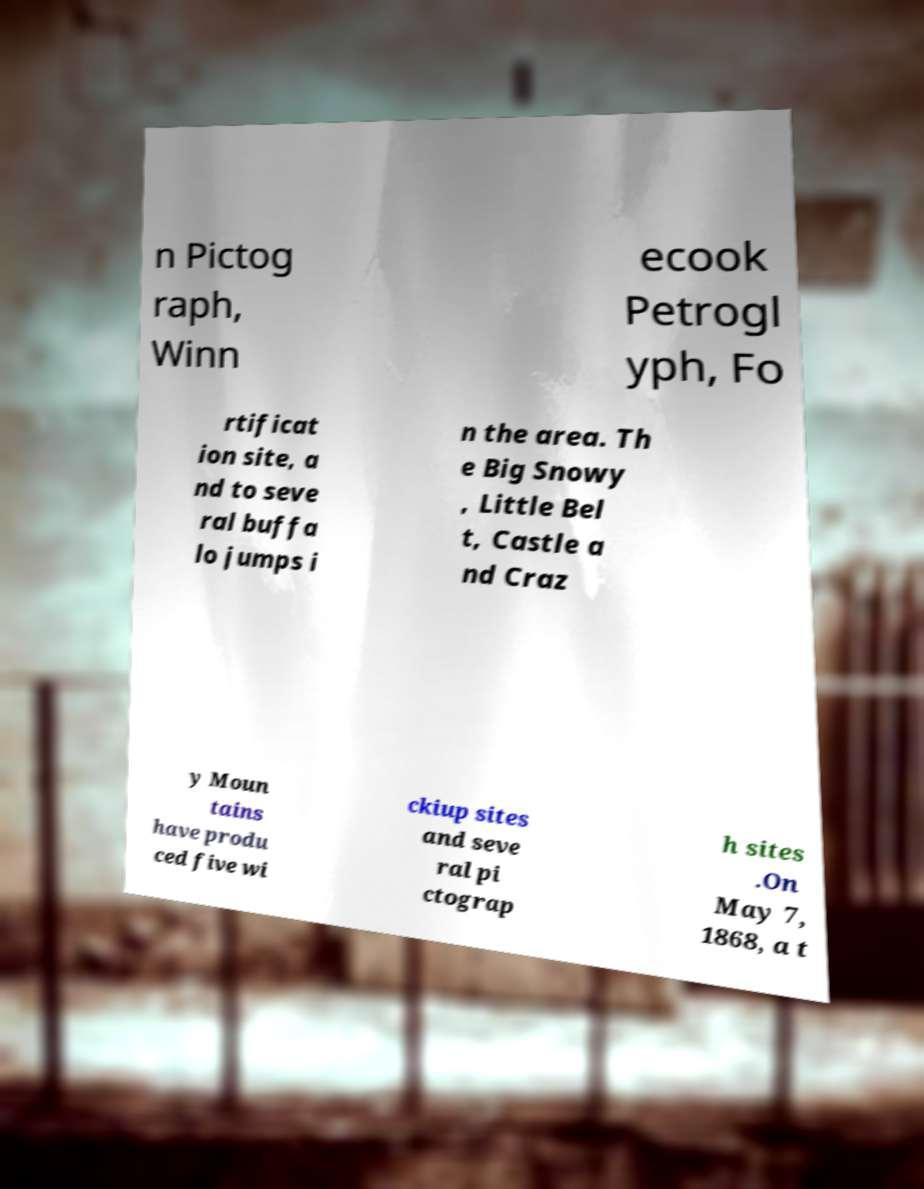Please read and relay the text visible in this image. What does it say? n Pictog raph, Winn ecook Petrogl yph, Fo rtificat ion site, a nd to seve ral buffa lo jumps i n the area. Th e Big Snowy , Little Bel t, Castle a nd Craz y Moun tains have produ ced five wi ckiup sites and seve ral pi ctograp h sites .On May 7, 1868, a t 